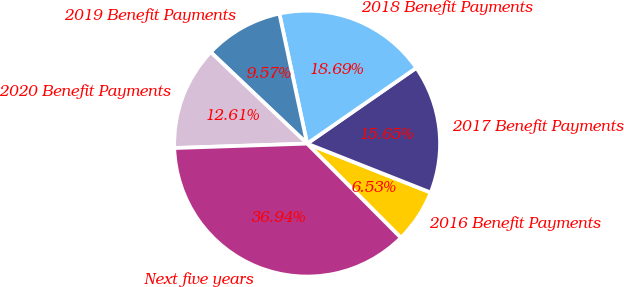Convert chart to OTSL. <chart><loc_0><loc_0><loc_500><loc_500><pie_chart><fcel>2016 Benefit Payments<fcel>2017 Benefit Payments<fcel>2018 Benefit Payments<fcel>2019 Benefit Payments<fcel>2020 Benefit Payments<fcel>Next five years<nl><fcel>6.53%<fcel>15.65%<fcel>18.69%<fcel>9.57%<fcel>12.61%<fcel>36.93%<nl></chart> 